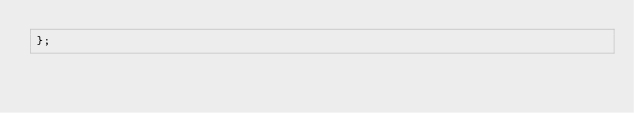Convert code to text. <code><loc_0><loc_0><loc_500><loc_500><_JavaScript_>};
</code> 